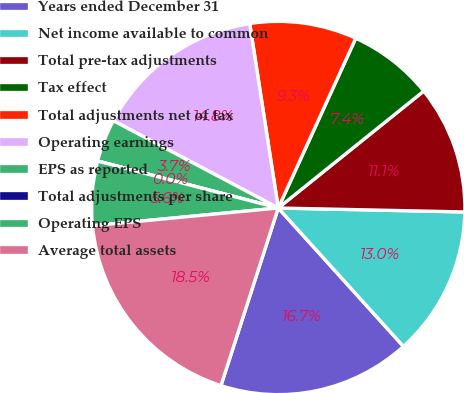<chart> <loc_0><loc_0><loc_500><loc_500><pie_chart><fcel>Years ended December 31<fcel>Net income available to common<fcel>Total pre-tax adjustments<fcel>Tax effect<fcel>Total adjustments net of tax<fcel>Operating earnings<fcel>EPS as reported<fcel>Total adjustments per share<fcel>Operating EPS<fcel>Average total assets<nl><fcel>16.67%<fcel>12.96%<fcel>11.11%<fcel>7.41%<fcel>9.26%<fcel>14.81%<fcel>3.7%<fcel>0.0%<fcel>5.56%<fcel>18.52%<nl></chart> 